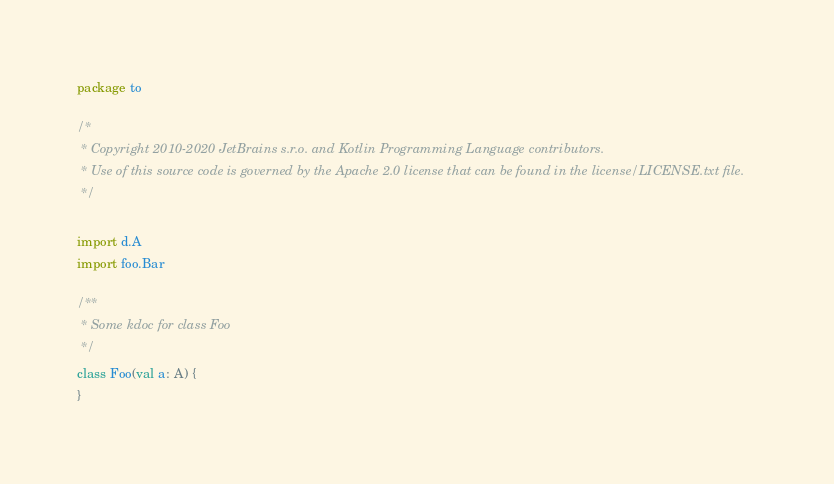Convert code to text. <code><loc_0><loc_0><loc_500><loc_500><_Kotlin_>package to

/*
 * Copyright 2010-2020 JetBrains s.r.o. and Kotlin Programming Language contributors.
 * Use of this source code is governed by the Apache 2.0 license that can be found in the license/LICENSE.txt file.
 */

import d.A
import foo.Bar

/**
 * Some kdoc for class Foo
 */
class Foo(val a: A) {
}
</code> 